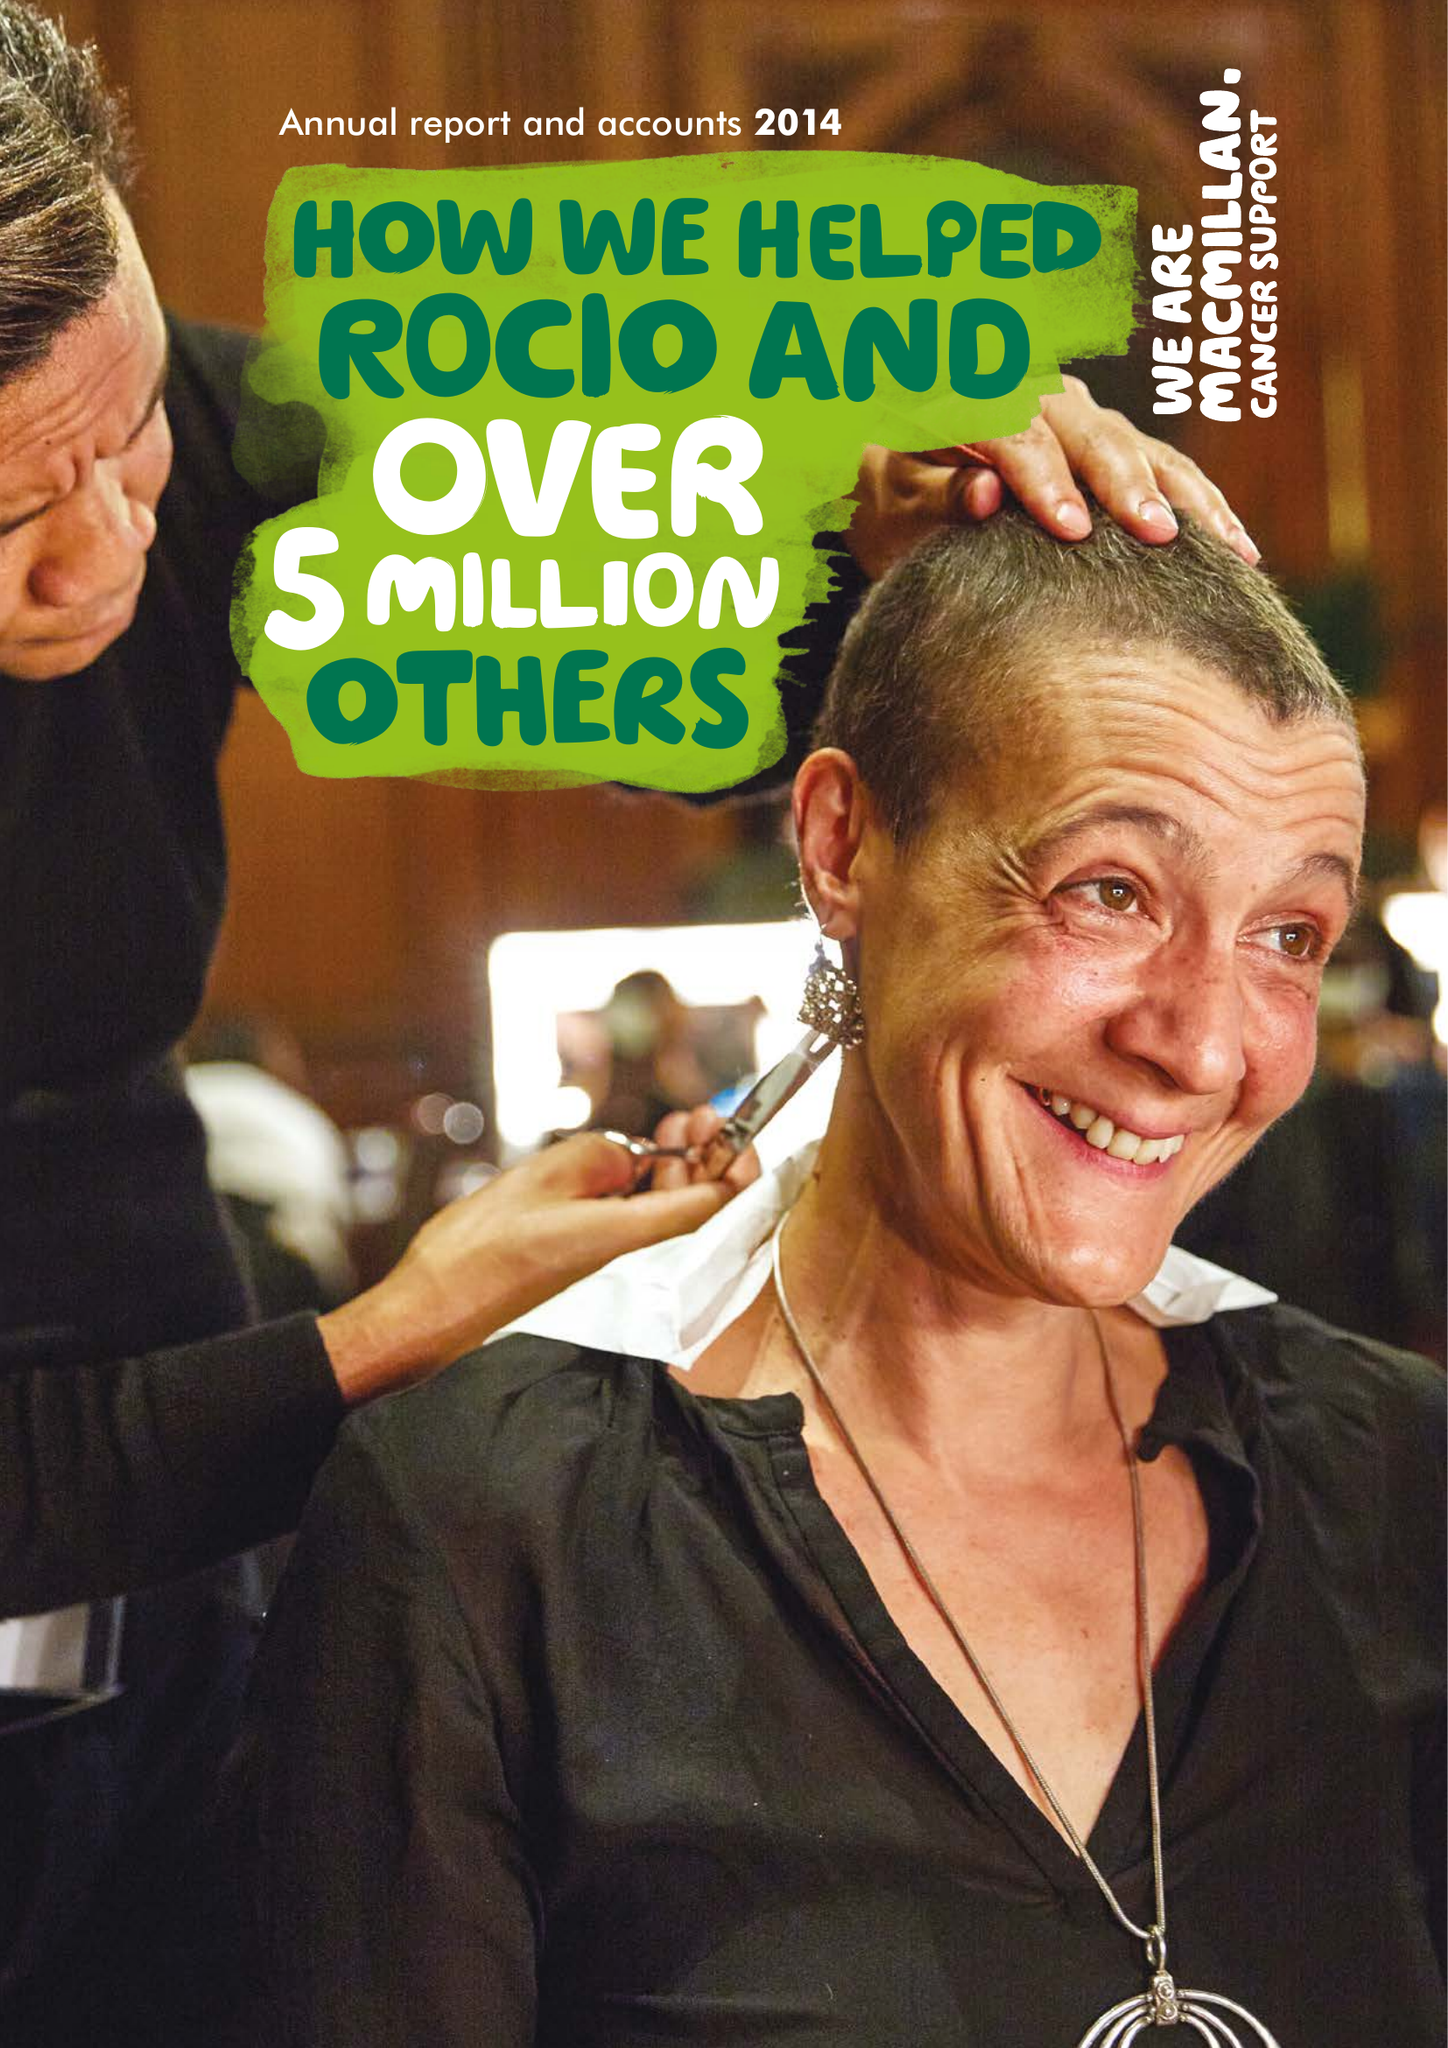What is the value for the report_date?
Answer the question using a single word or phrase. 2014-12-31 